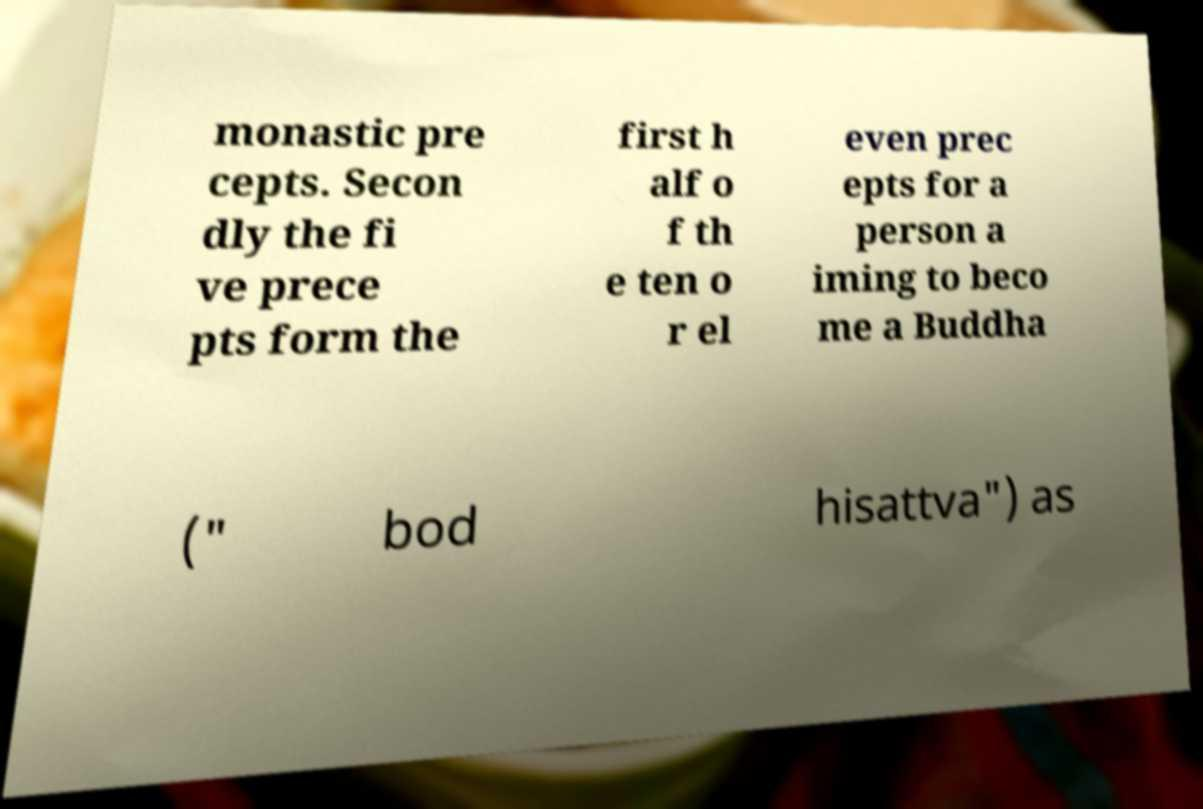Could you extract and type out the text from this image? monastic pre cepts. Secon dly the fi ve prece pts form the first h alf o f th e ten o r el even prec epts for a person a iming to beco me a Buddha (" bod hisattva") as 